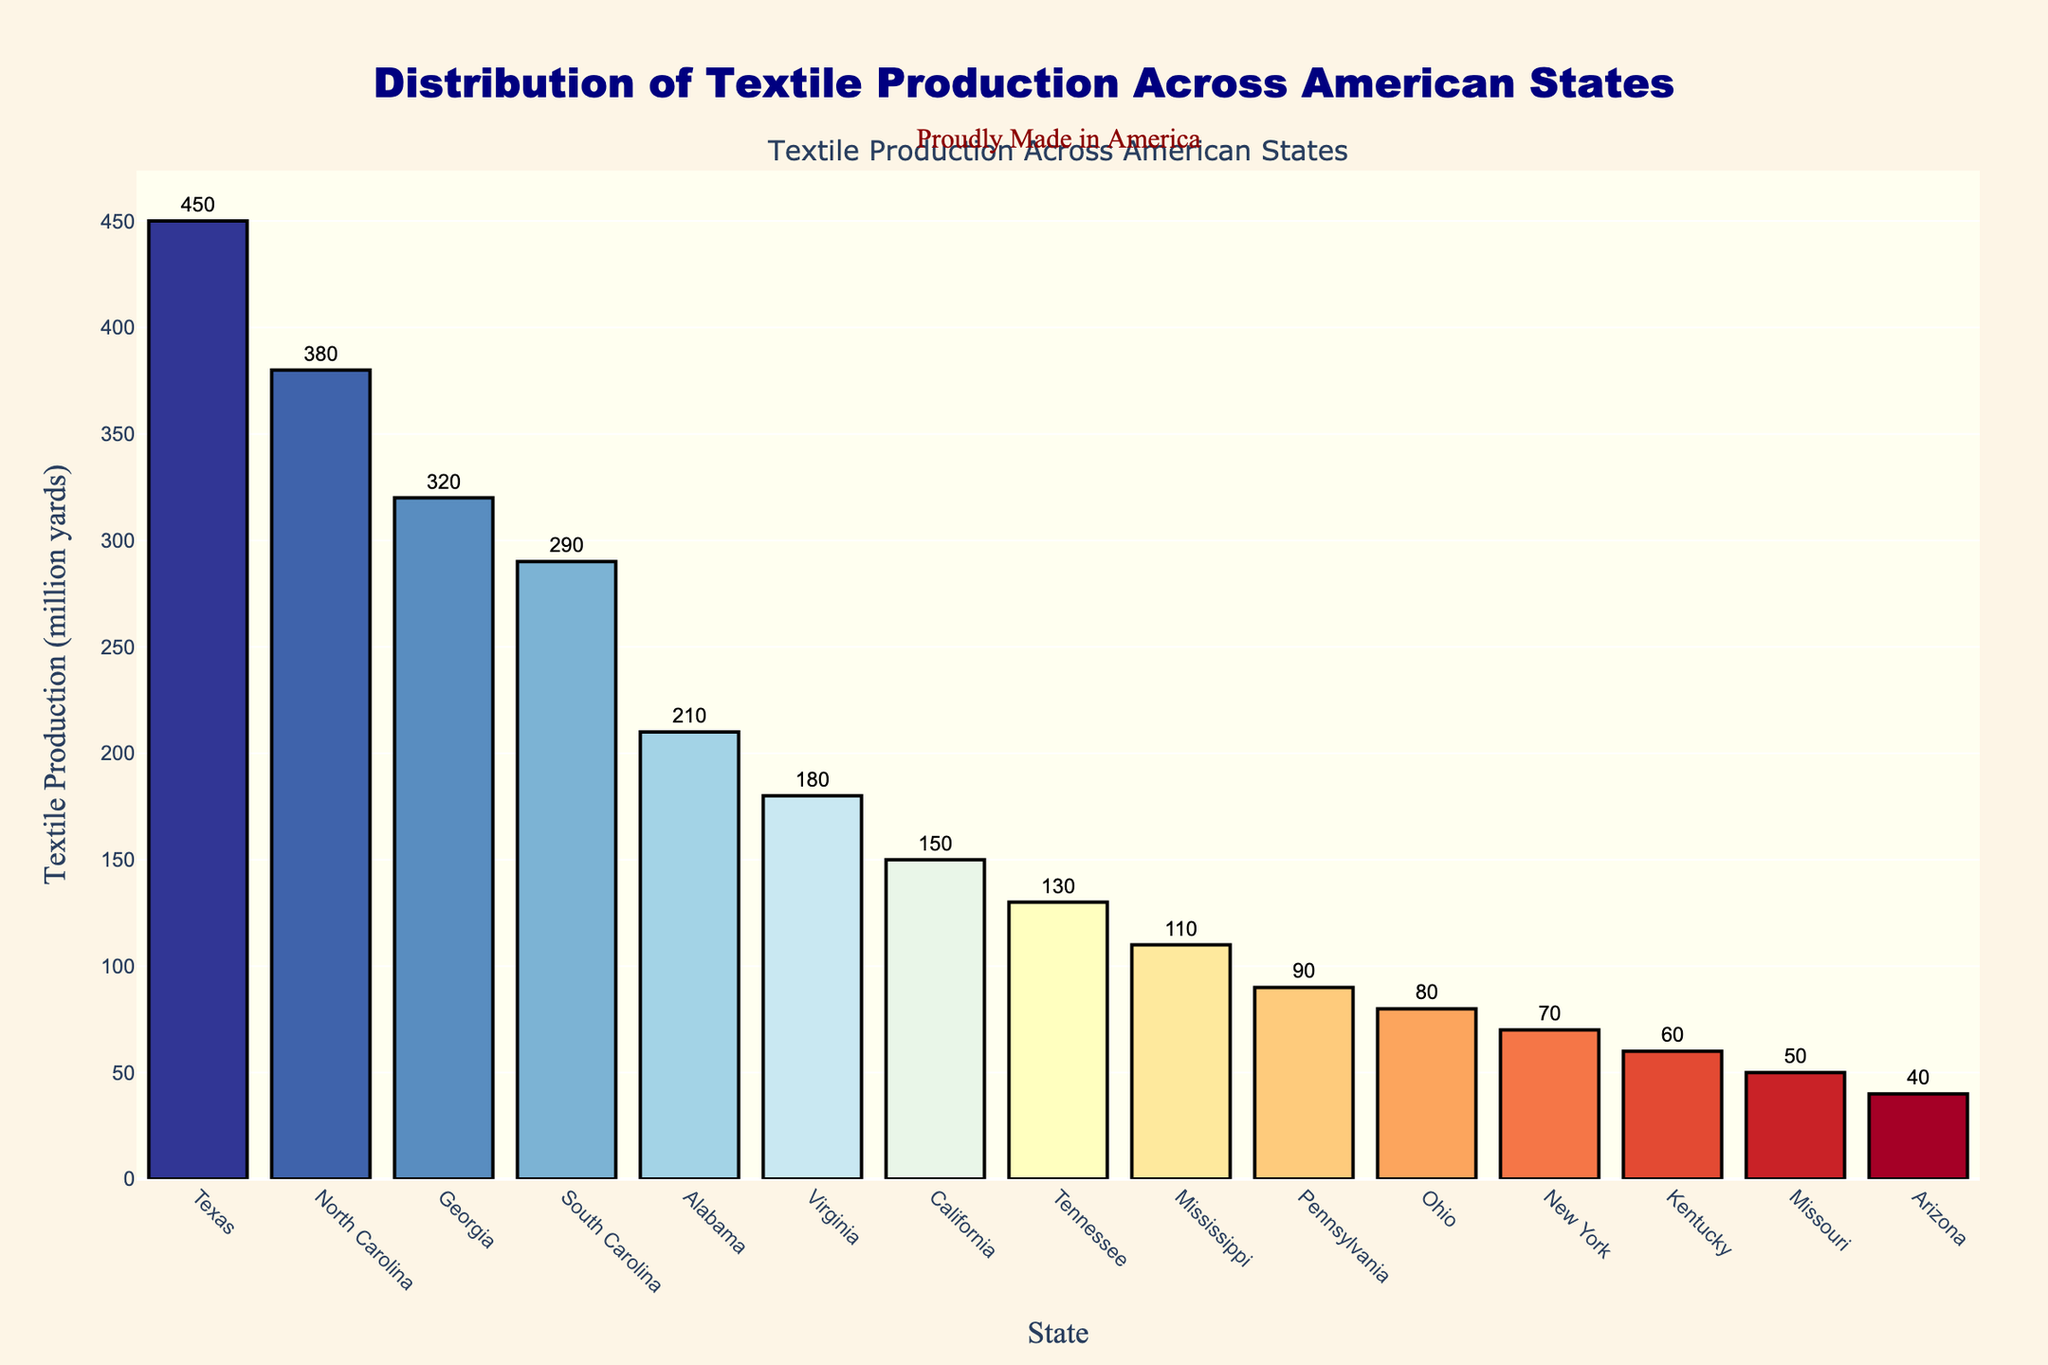Which state has the highest textile production? By referring to the bar chart and comparing the heights of the bars, we see that Texas has the highest textile production.
Answer: Texas How much more textile production does Texas have than North Carolina? Texas has 450 million yards of textile production, while North Carolina has 380 million yards. The difference is 450 - 380 = 70 million yards.
Answer: 70 million yards Which states have a textile production of over 300 million yards? By examining the chart, we see that Texas (450), North Carolina (380), and Georgia (320) have textile production values over 300 million yards.
Answer: Texas, North Carolina, Georgia What is the total textile production of the top three states combined? The top three states are Texas (450), North Carolina (380), and Georgia (320). Summing these values gives us 450 + 380 + 320 = 1150 million yards.
Answer: 1150 million yards Which state has the lowest textile production, and what is its value? Checking the bar with the shortest height, we find that Arizona has the lowest textile production at 40 million yards.
Answer: Arizona, 40 million yards How does Pennsylvania’s textile production compare to Tennessee’s? Refer to the chart and compare the heights of Pennsylvania’s bar (90 million yards) with Tennessee’s (130 million yards). Tennessee’s textile production is greater.
Answer: Tennessee has more What is the median textile production value across all states? First, we list the production values in ascending order: 40, 50, 60, 70, 80, 90, 110, 130, 150, 180, 210, 290, 320, 380, 450. There are 15 values, so the median is the 8th value, which is 130 million yards.
Answer: 130 million yards What is the approximate average textile production of the states listed? Add up all the production values and divide by the number of states: (450+380+320+290+210+180+150+130+110+90+80+70+60+50+40) / 15 = 2610 / 15 ≈ 174 million yards.
Answer: 174 million yards Which states have a textile production between 100 and 200 million yards? Referring to the chart, Virginia (180), California (150), Tennessee (130), and Mississippi (110) fall within this range.
Answer: Virginia, California, Tennessee, Mississippi 